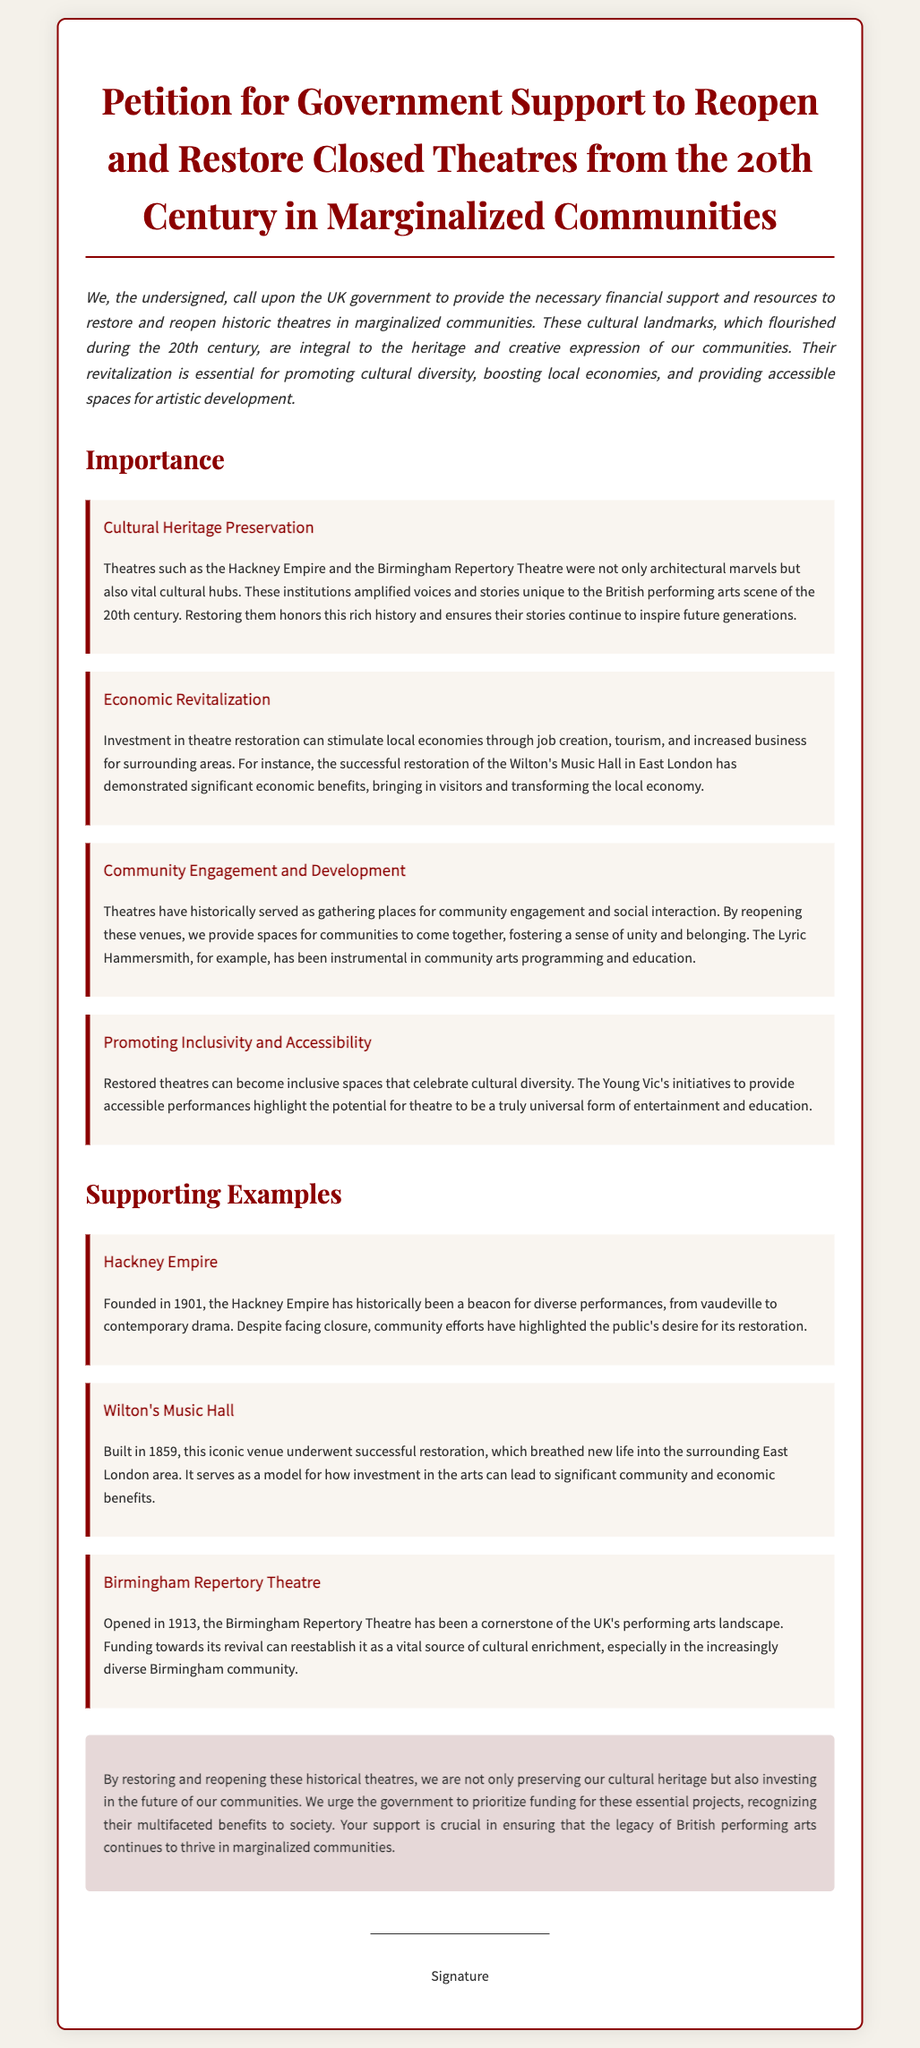What is the title of the petition? The title of the petition is clearly stated at the top of the document, focusing on the restoration and reopening of theatres.
Answer: Petition for Government Support to Reopen and Restore Closed Theatres from the 20th Century in Marginalized Communities What year was the Hackney Empire founded? The foundation year of the Hackney Empire is mentioned in the document as a significant historical detail.
Answer: 1901 Which theatre was built in 1859? This question asks for a specific example of a theatre and its foundation year provided in the document.
Answer: Wilton's Music Hall What is one potential economic benefit of theatre restoration mentioned? The document lists several economic benefits, including job creation and tourism.
Answer: Job creation Which theatre serves as a model for community and economic benefits after restoration? The document states specific theatres and highlights one as a successful example of restoration benefits.
Answer: Wilton's Music Hall What is highlighted as a vital cultural hub in the petition? The petition emphasizes the significance of certain theatres in cultural heritage preservation.
Answer: Hackney Empire What year did the Birmingham Repertory Theatre open? The opening year of the Birmingham Repertory Theatre is provided as context to its historical importance.
Answer: 1913 What are the two main types of theatres discussed in the petition? The petition categorizes the theatres by their cultural importance and historical context.
Answer: Historic theatres How does the petition propose to enhance community engagement? The petition describes how reopening theatres facilitates community interaction and development.
Answer: Providing spaces for communities to come together 